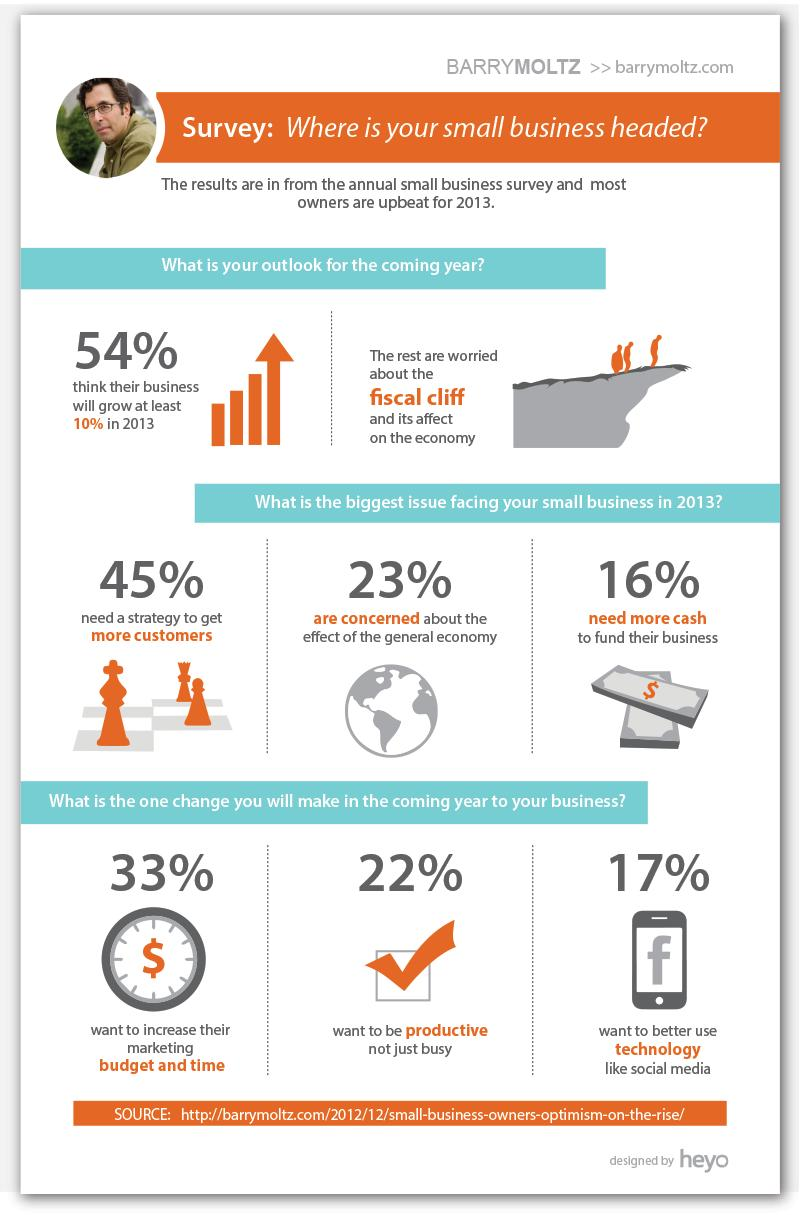Indicate a few pertinent items in this graphic. In the survey, 46% of respondents believe that their business will not grow by at least 10%. The biggest change that needs to be made is increasing the marketing budget and time. 